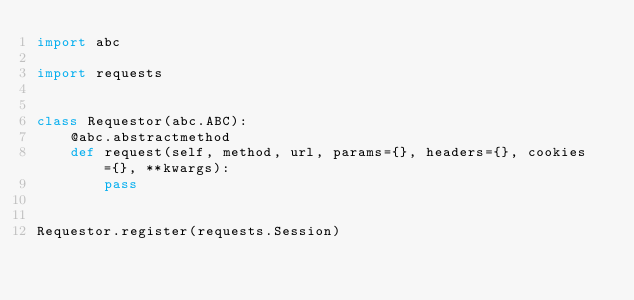Convert code to text. <code><loc_0><loc_0><loc_500><loc_500><_Python_>import abc

import requests


class Requestor(abc.ABC):
    @abc.abstractmethod
    def request(self, method, url, params={}, headers={}, cookies={}, **kwargs):
        pass


Requestor.register(requests.Session)
</code> 